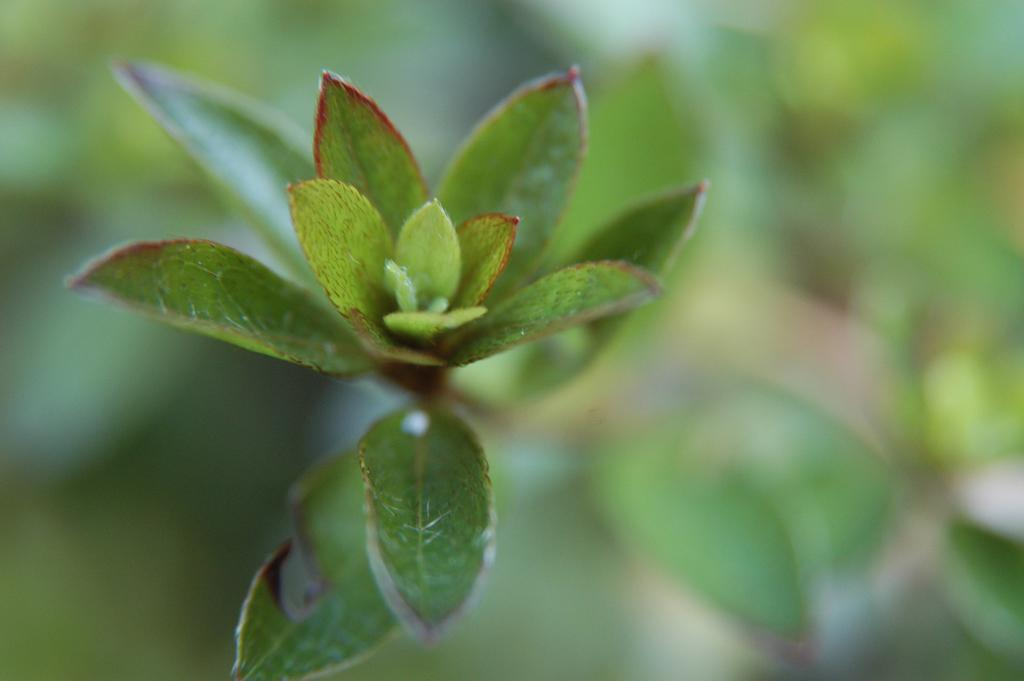What is the main subject of the image? The main subject of the image is the leaves of a tree. What colors are the leaves in the image? The leaves are green and red in color. Can you describe the background of the image? The background of the image is blurry. Where is the vase placed in the image? There is no vase present in the image. What type of development can be seen taking place in the image? There is no development or construction activity visible in the image; it features leaves of a tree. 